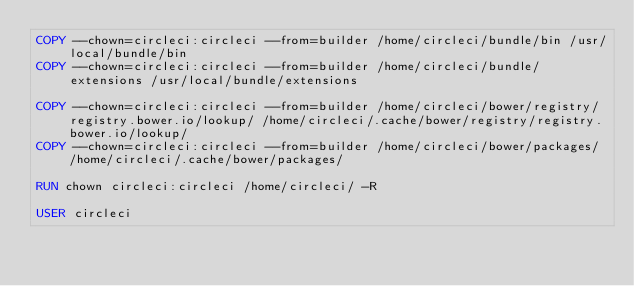Convert code to text. <code><loc_0><loc_0><loc_500><loc_500><_Dockerfile_>COPY --chown=circleci:circleci --from=builder /home/circleci/bundle/bin /usr/local/bundle/bin
COPY --chown=circleci:circleci --from=builder /home/circleci/bundle/extensions /usr/local/bundle/extensions

COPY --chown=circleci:circleci --from=builder /home/circleci/bower/registry/registry.bower.io/lookup/ /home/circleci/.cache/bower/registry/registry.bower.io/lookup/
COPY --chown=circleci:circleci --from=builder /home/circleci/bower/packages/ /home/circleci/.cache/bower/packages/

RUN chown circleci:circleci /home/circleci/ -R

USER circleci
</code> 